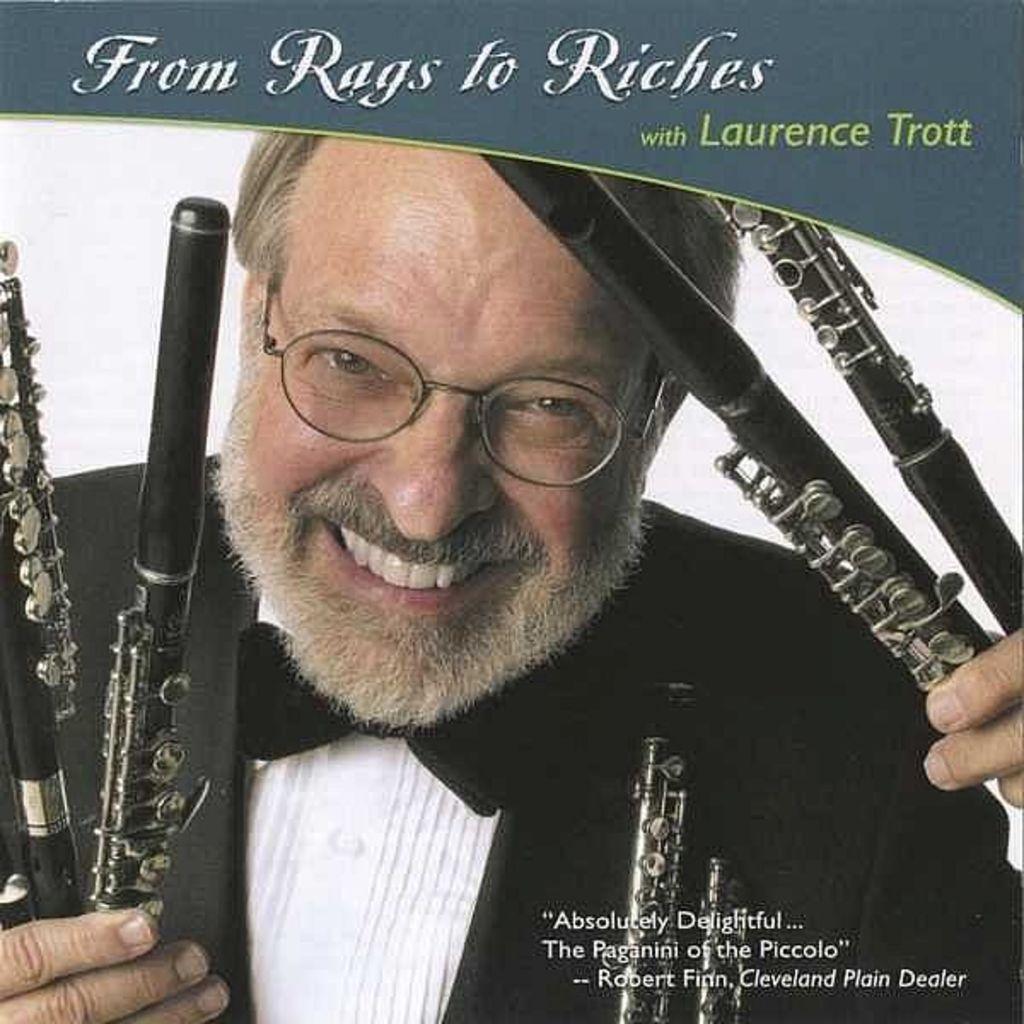Describe this image in one or two sentences. In this image we can see the poster with some text and there is a person holding some objects which looks like a musical instrument. 